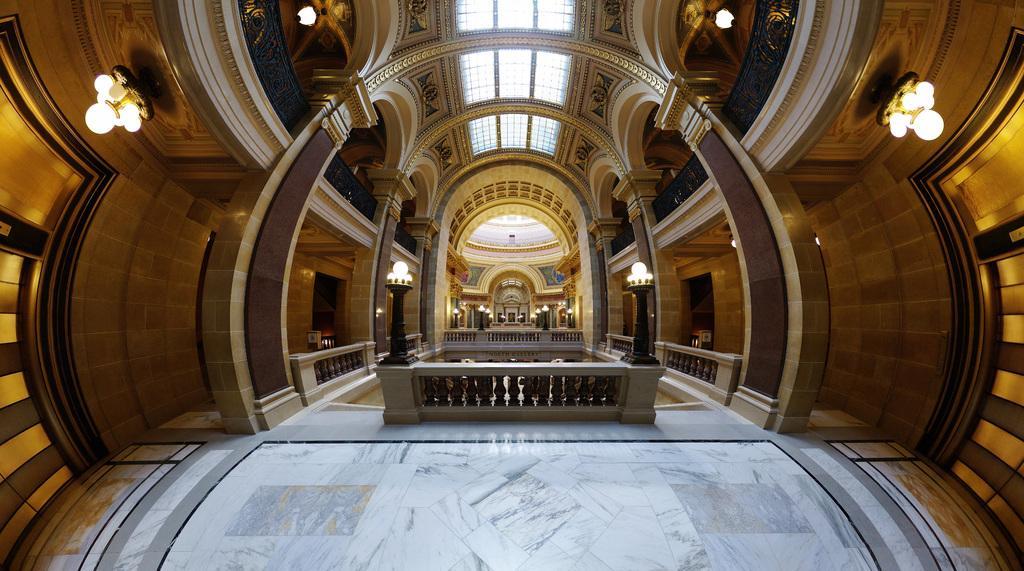In one or two sentences, can you explain what this image depicts? A picture inside of a building. In this buildings we can see lights, wall, pillars, fence and roof. 